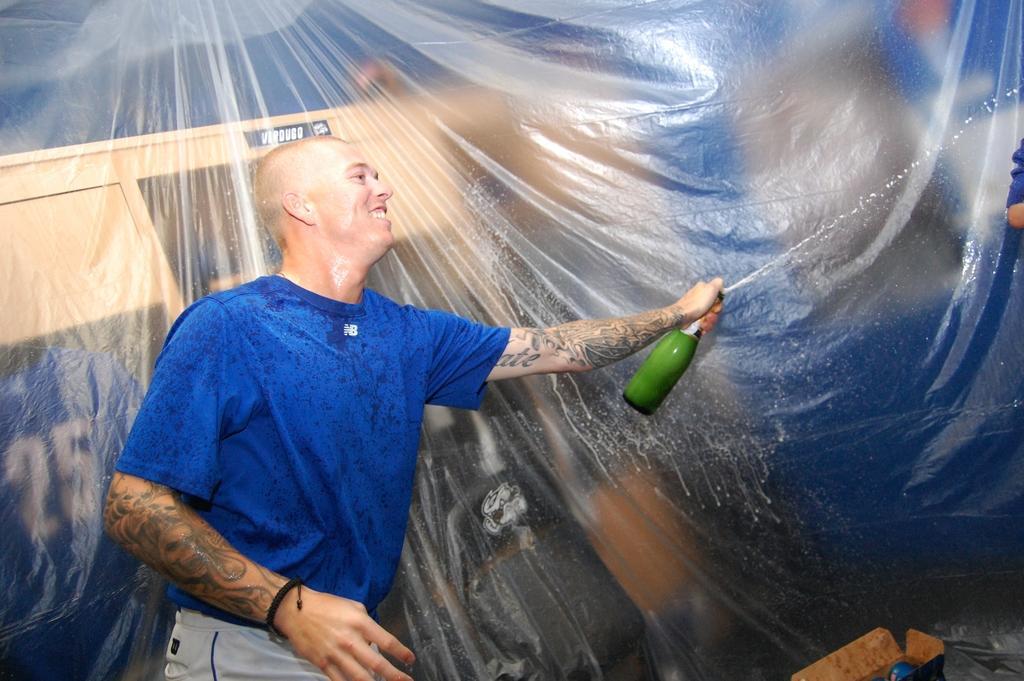In one or two sentences, can you explain what this image depicts? In this image there is a man who is wearing the blue dress is holding the bear bottle with his hand. There is a tattoo on his hand. In the background there is a cover. Behind the cover there is blur. At the bottom there is a box. On the right side there is a person. 